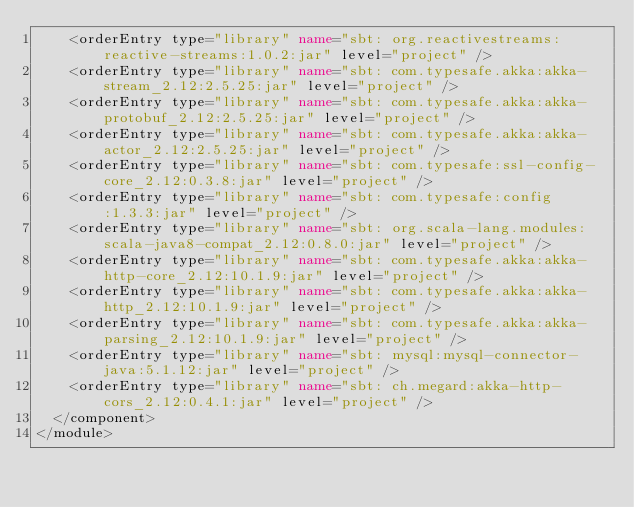<code> <loc_0><loc_0><loc_500><loc_500><_XML_>    <orderEntry type="library" name="sbt: org.reactivestreams:reactive-streams:1.0.2:jar" level="project" />
    <orderEntry type="library" name="sbt: com.typesafe.akka:akka-stream_2.12:2.5.25:jar" level="project" />
    <orderEntry type="library" name="sbt: com.typesafe.akka:akka-protobuf_2.12:2.5.25:jar" level="project" />
    <orderEntry type="library" name="sbt: com.typesafe.akka:akka-actor_2.12:2.5.25:jar" level="project" />
    <orderEntry type="library" name="sbt: com.typesafe:ssl-config-core_2.12:0.3.8:jar" level="project" />
    <orderEntry type="library" name="sbt: com.typesafe:config:1.3.3:jar" level="project" />
    <orderEntry type="library" name="sbt: org.scala-lang.modules:scala-java8-compat_2.12:0.8.0:jar" level="project" />
    <orderEntry type="library" name="sbt: com.typesafe.akka:akka-http-core_2.12:10.1.9:jar" level="project" />
    <orderEntry type="library" name="sbt: com.typesafe.akka:akka-http_2.12:10.1.9:jar" level="project" />
    <orderEntry type="library" name="sbt: com.typesafe.akka:akka-parsing_2.12:10.1.9:jar" level="project" />
    <orderEntry type="library" name="sbt: mysql:mysql-connector-java:5.1.12:jar" level="project" />
    <orderEntry type="library" name="sbt: ch.megard:akka-http-cors_2.12:0.4.1:jar" level="project" />
  </component>
</module></code> 